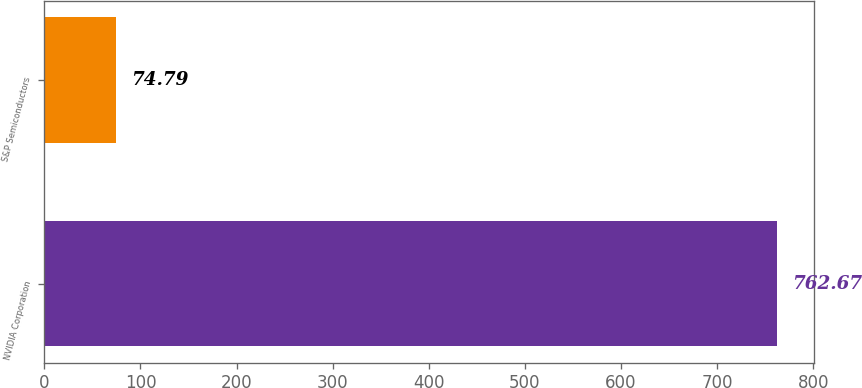Convert chart to OTSL. <chart><loc_0><loc_0><loc_500><loc_500><bar_chart><fcel>NVIDIA Corporation<fcel>S&P Semiconductors<nl><fcel>762.67<fcel>74.79<nl></chart> 